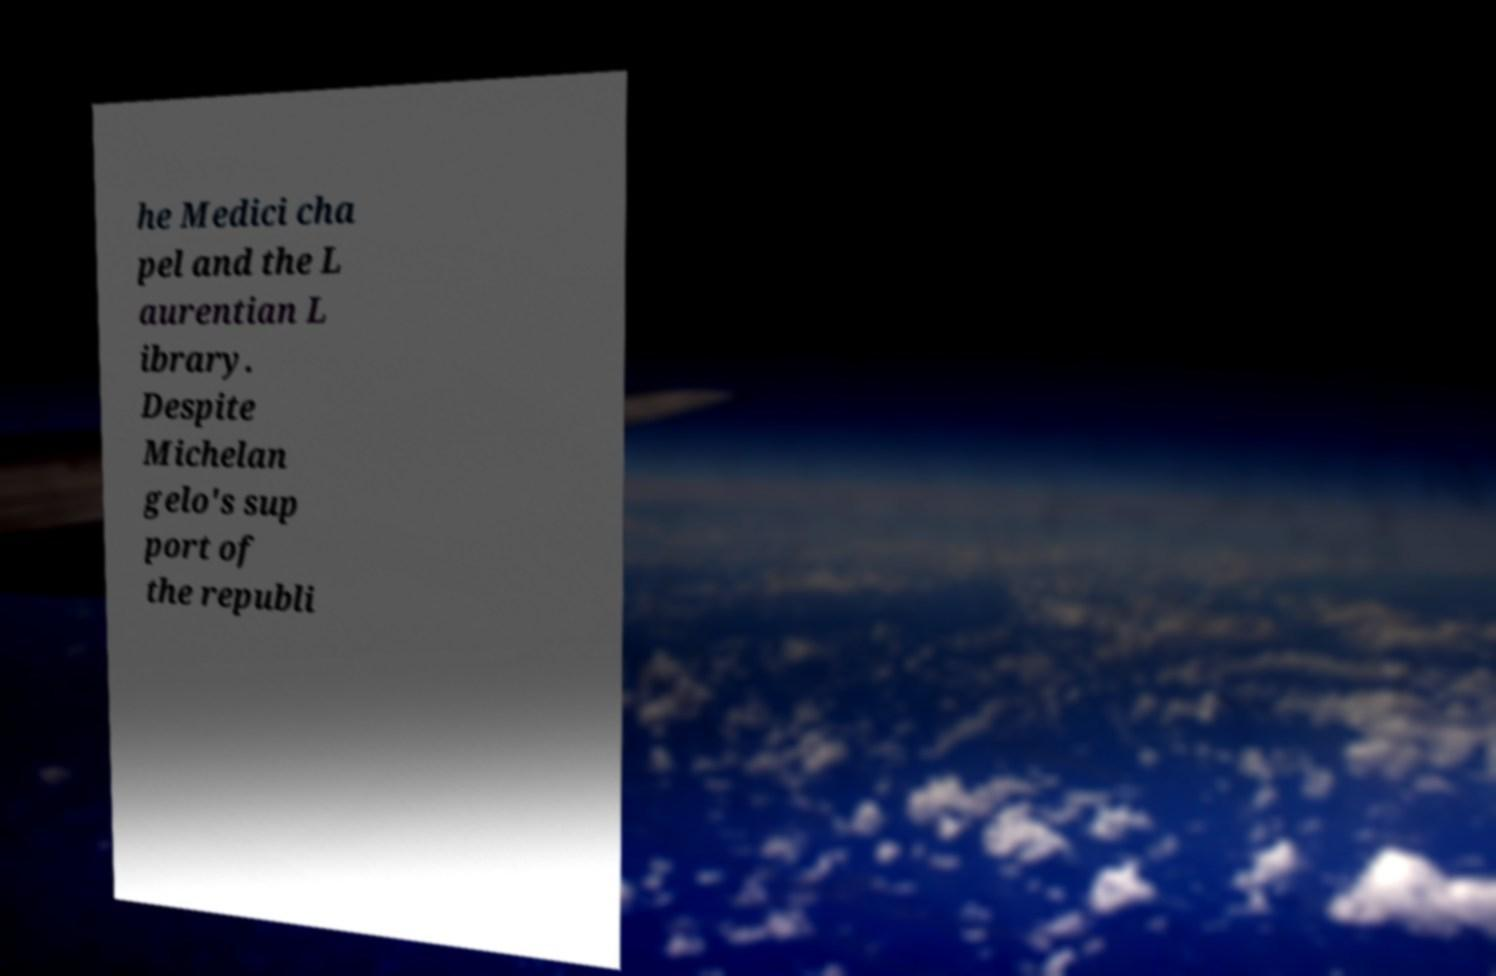What messages or text are displayed in this image? I need them in a readable, typed format. he Medici cha pel and the L aurentian L ibrary. Despite Michelan gelo's sup port of the republi 